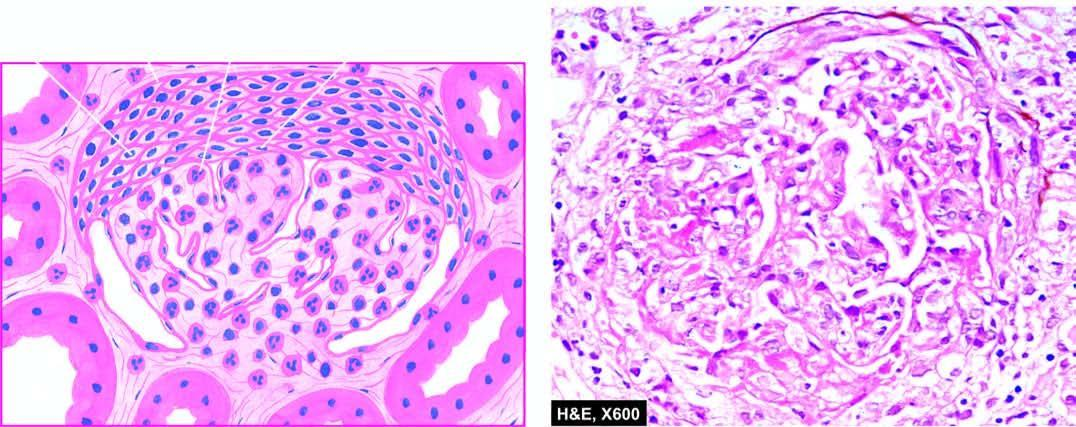does the cyst wall show hypercellularity and leucocytic infiltration?
Answer the question using a single word or phrase. No 